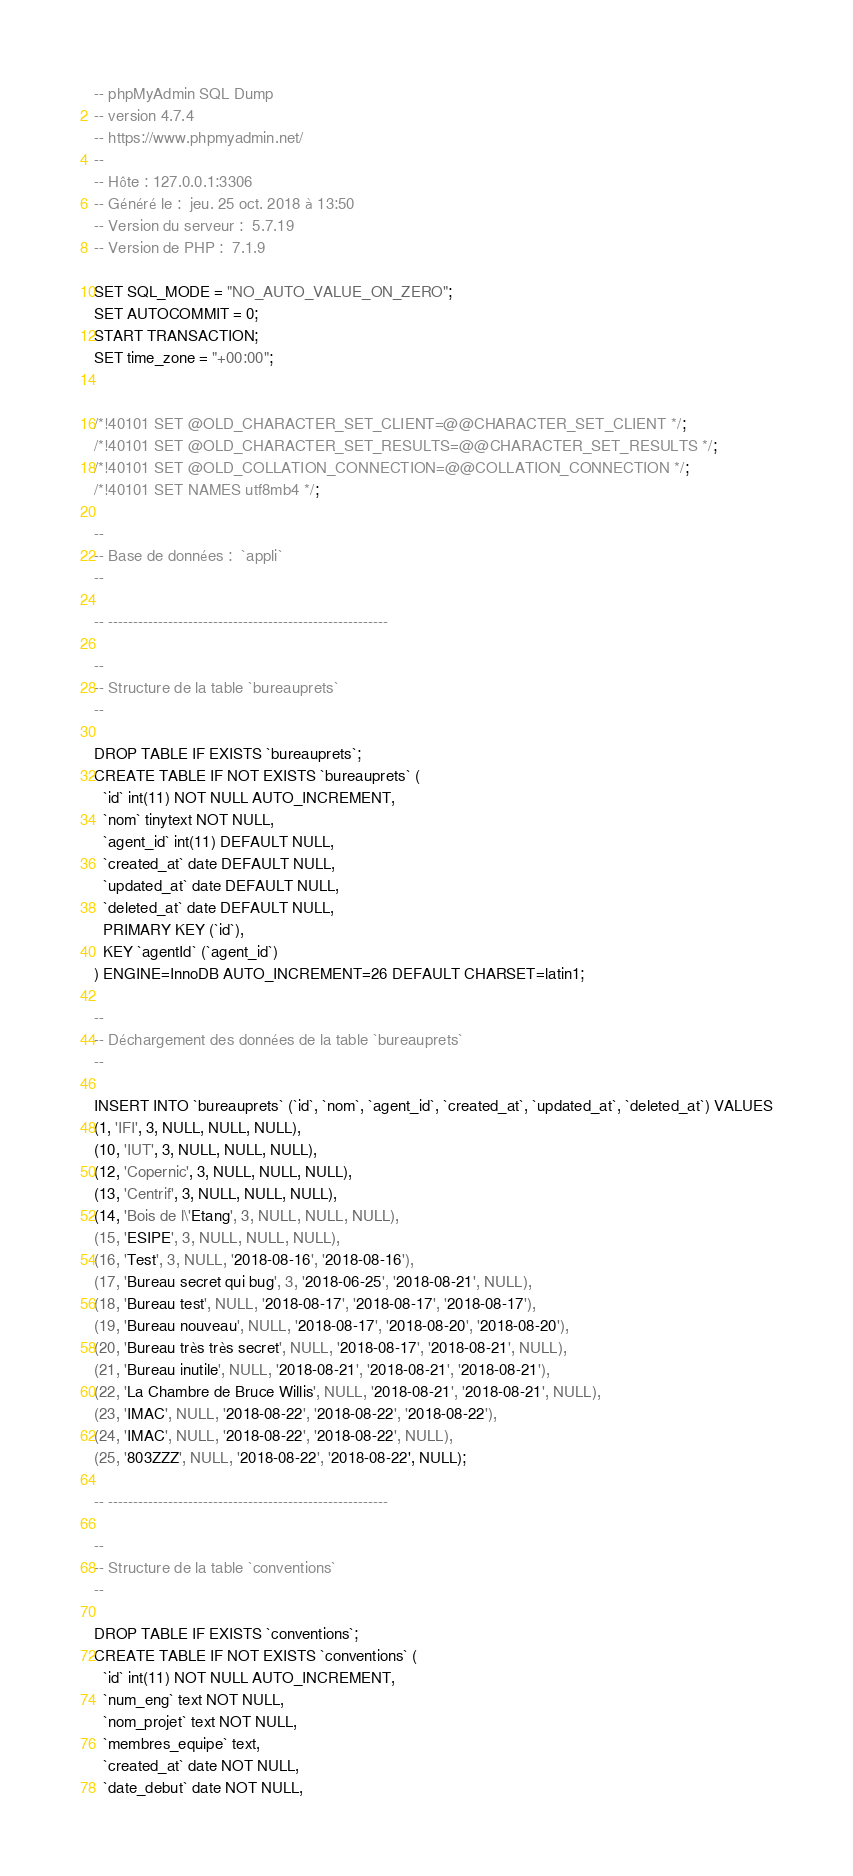<code> <loc_0><loc_0><loc_500><loc_500><_SQL_>-- phpMyAdmin SQL Dump
-- version 4.7.4
-- https://www.phpmyadmin.net/
--
-- Hôte : 127.0.0.1:3306
-- Généré le :  jeu. 25 oct. 2018 à 13:50
-- Version du serveur :  5.7.19
-- Version de PHP :  7.1.9

SET SQL_MODE = "NO_AUTO_VALUE_ON_ZERO";
SET AUTOCOMMIT = 0;
START TRANSACTION;
SET time_zone = "+00:00";


/*!40101 SET @OLD_CHARACTER_SET_CLIENT=@@CHARACTER_SET_CLIENT */;
/*!40101 SET @OLD_CHARACTER_SET_RESULTS=@@CHARACTER_SET_RESULTS */;
/*!40101 SET @OLD_COLLATION_CONNECTION=@@COLLATION_CONNECTION */;
/*!40101 SET NAMES utf8mb4 */;

--
-- Base de données :  `appli`
--

-- --------------------------------------------------------

--
-- Structure de la table `bureauprets`
--

DROP TABLE IF EXISTS `bureauprets`;
CREATE TABLE IF NOT EXISTS `bureauprets` (
  `id` int(11) NOT NULL AUTO_INCREMENT,
  `nom` tinytext NOT NULL,
  `agent_id` int(11) DEFAULT NULL,
  `created_at` date DEFAULT NULL,
  `updated_at` date DEFAULT NULL,
  `deleted_at` date DEFAULT NULL,
  PRIMARY KEY (`id`),
  KEY `agentId` (`agent_id`)
) ENGINE=InnoDB AUTO_INCREMENT=26 DEFAULT CHARSET=latin1;

--
-- Déchargement des données de la table `bureauprets`
--

INSERT INTO `bureauprets` (`id`, `nom`, `agent_id`, `created_at`, `updated_at`, `deleted_at`) VALUES
(1, 'IFI', 3, NULL, NULL, NULL),
(10, 'IUT', 3, NULL, NULL, NULL),
(12, 'Copernic', 3, NULL, NULL, NULL),
(13, 'Centrif', 3, NULL, NULL, NULL),
(14, 'Bois de l\'Etang', 3, NULL, NULL, NULL),
(15, 'ESIPE', 3, NULL, NULL, NULL),
(16, 'Test', 3, NULL, '2018-08-16', '2018-08-16'),
(17, 'Bureau secret qui bug', 3, '2018-06-25', '2018-08-21', NULL),
(18, 'Bureau test', NULL, '2018-08-17', '2018-08-17', '2018-08-17'),
(19, 'Bureau nouveau', NULL, '2018-08-17', '2018-08-20', '2018-08-20'),
(20, 'Bureau très très secret', NULL, '2018-08-17', '2018-08-21', NULL),
(21, 'Bureau inutile', NULL, '2018-08-21', '2018-08-21', '2018-08-21'),
(22, 'La Chambre de Bruce Willis', NULL, '2018-08-21', '2018-08-21', NULL),
(23, 'IMAC', NULL, '2018-08-22', '2018-08-22', '2018-08-22'),
(24, 'IMAC', NULL, '2018-08-22', '2018-08-22', NULL),
(25, '803ZZZ', NULL, '2018-08-22', '2018-08-22', NULL);

-- --------------------------------------------------------

--
-- Structure de la table `conventions`
--

DROP TABLE IF EXISTS `conventions`;
CREATE TABLE IF NOT EXISTS `conventions` (
  `id` int(11) NOT NULL AUTO_INCREMENT,
  `num_eng` text NOT NULL,
  `nom_projet` text NOT NULL,
  `membres_equipe` text,
  `created_at` date NOT NULL,
  `date_debut` date NOT NULL,</code> 